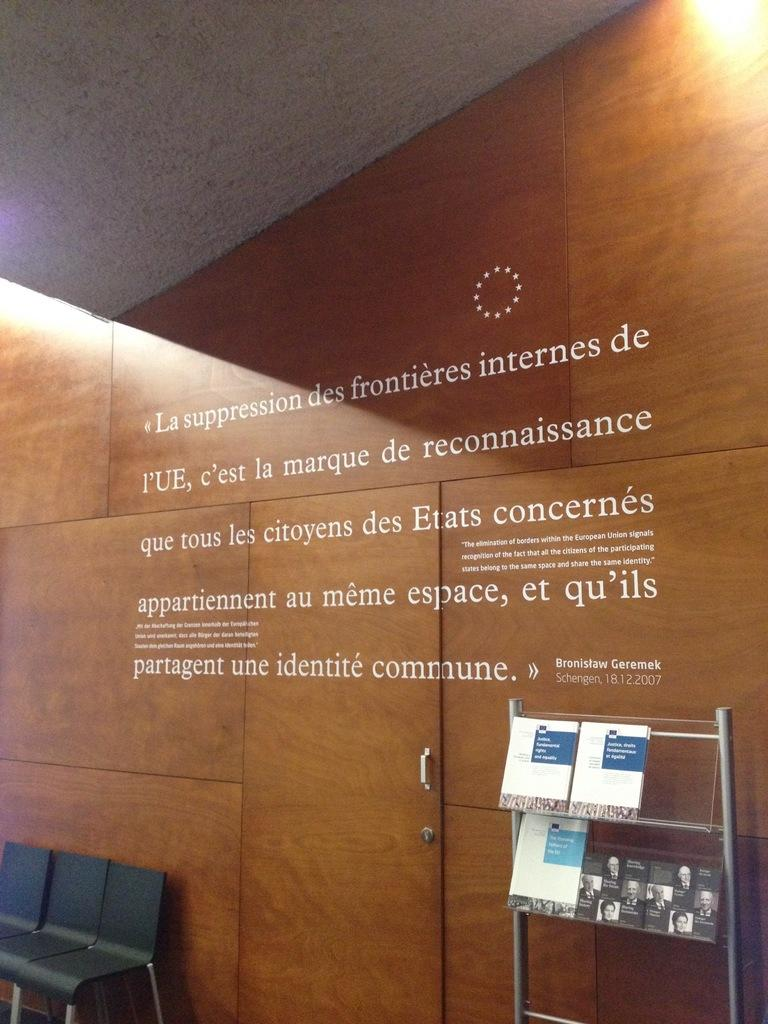What type of furniture can be seen in the image? There are chairs in the image. What architectural feature is present in the image? There is a door in the image. What is the purpose of the stand in the image? The stand is likely used to hold or display items. What type of reading material is available in the image? There are magazines on racks in the image. What part of the building is visible in the image? The rooftop is visible in the image. What type of surface is present in the image? There is a wall in the image. What is written or displayed on the wall? There is text on the wall. Can you see any poisonous substances on the chairs in the image? There is no mention of poisonous substances in the image; it only features chairs, a door, a stand, magazines, the rooftop, a wall, and text on the wall. Is there a boat visible on the rooftop in the image? There is no boat present on the rooftop in the image. 